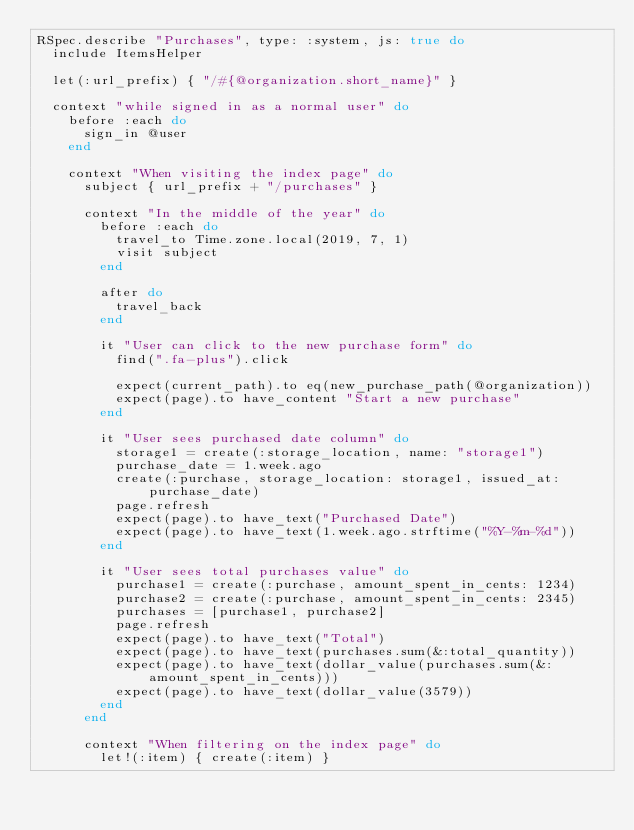<code> <loc_0><loc_0><loc_500><loc_500><_Ruby_>RSpec.describe "Purchases", type: :system, js: true do
  include ItemsHelper

  let(:url_prefix) { "/#{@organization.short_name}" }

  context "while signed in as a normal user" do
    before :each do
      sign_in @user
    end

    context "When visiting the index page" do
      subject { url_prefix + "/purchases" }

      context "In the middle of the year" do
        before :each do
          travel_to Time.zone.local(2019, 7, 1)
          visit subject
        end

        after do
          travel_back
        end

        it "User can click to the new purchase form" do
          find(".fa-plus").click

          expect(current_path).to eq(new_purchase_path(@organization))
          expect(page).to have_content "Start a new purchase"
        end

        it "User sees purchased date column" do
          storage1 = create(:storage_location, name: "storage1")
          purchase_date = 1.week.ago
          create(:purchase, storage_location: storage1, issued_at: purchase_date)
          page.refresh
          expect(page).to have_text("Purchased Date")
          expect(page).to have_text(1.week.ago.strftime("%Y-%m-%d"))
        end

        it "User sees total purchases value" do
          purchase1 = create(:purchase, amount_spent_in_cents: 1234)
          purchase2 = create(:purchase, amount_spent_in_cents: 2345)
          purchases = [purchase1, purchase2]
          page.refresh
          expect(page).to have_text("Total")
          expect(page).to have_text(purchases.sum(&:total_quantity))
          expect(page).to have_text(dollar_value(purchases.sum(&:amount_spent_in_cents)))
          expect(page).to have_text(dollar_value(3579))
        end
      end

      context "When filtering on the index page" do
        let!(:item) { create(:item) }</code> 